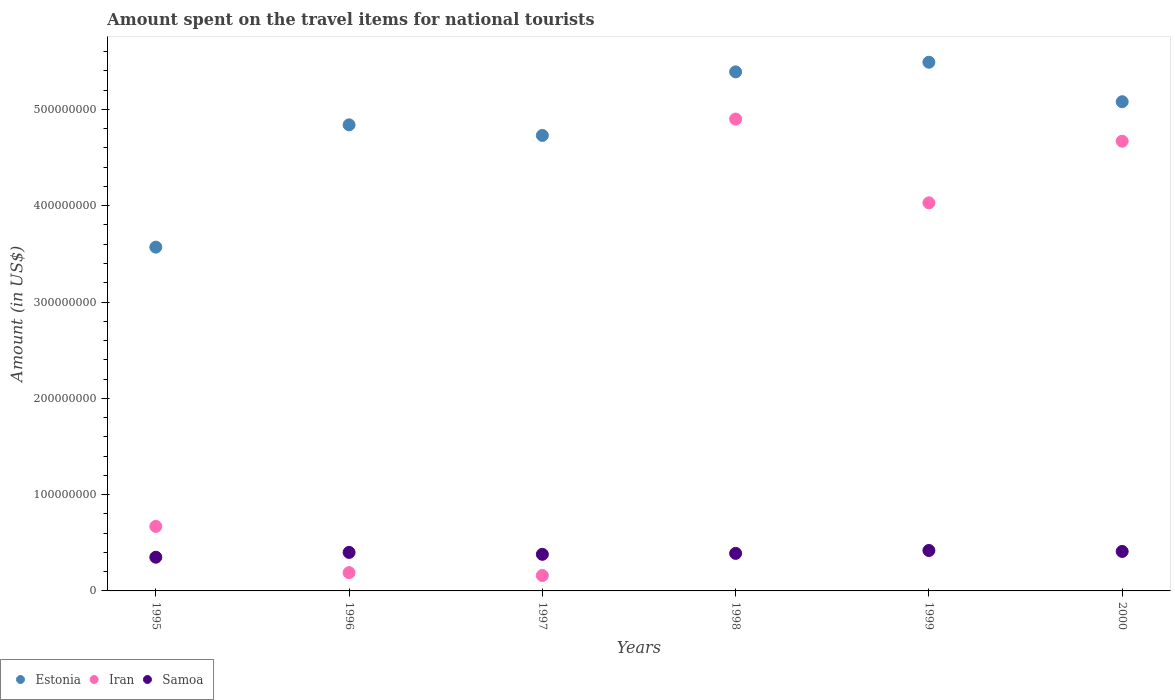How many different coloured dotlines are there?
Your response must be concise. 3. What is the amount spent on the travel items for national tourists in Estonia in 1998?
Your answer should be compact. 5.39e+08. Across all years, what is the maximum amount spent on the travel items for national tourists in Estonia?
Make the answer very short. 5.49e+08. Across all years, what is the minimum amount spent on the travel items for national tourists in Estonia?
Your response must be concise. 3.57e+08. In which year was the amount spent on the travel items for national tourists in Estonia maximum?
Provide a short and direct response. 1999. In which year was the amount spent on the travel items for national tourists in Samoa minimum?
Ensure brevity in your answer.  1995. What is the total amount spent on the travel items for national tourists in Samoa in the graph?
Your answer should be very brief. 2.35e+08. What is the difference between the amount spent on the travel items for national tourists in Samoa in 1995 and that in 1999?
Your response must be concise. -7.00e+06. What is the difference between the amount spent on the travel items for national tourists in Estonia in 1997 and the amount spent on the travel items for national tourists in Iran in 2000?
Provide a succinct answer. 6.00e+06. What is the average amount spent on the travel items for national tourists in Estonia per year?
Your answer should be very brief. 4.85e+08. In the year 1998, what is the difference between the amount spent on the travel items for national tourists in Estonia and amount spent on the travel items for national tourists in Iran?
Provide a succinct answer. 4.90e+07. In how many years, is the amount spent on the travel items for national tourists in Estonia greater than 380000000 US$?
Offer a terse response. 5. What is the ratio of the amount spent on the travel items for national tourists in Estonia in 1996 to that in 1998?
Provide a short and direct response. 0.9. What is the difference between the highest and the second highest amount spent on the travel items for national tourists in Estonia?
Provide a succinct answer. 1.00e+07. What is the difference between the highest and the lowest amount spent on the travel items for national tourists in Samoa?
Your response must be concise. 7.00e+06. Is it the case that in every year, the sum of the amount spent on the travel items for national tourists in Samoa and amount spent on the travel items for national tourists in Iran  is greater than the amount spent on the travel items for national tourists in Estonia?
Keep it short and to the point. No. Are the values on the major ticks of Y-axis written in scientific E-notation?
Make the answer very short. No. Does the graph contain any zero values?
Offer a terse response. No. Does the graph contain grids?
Offer a very short reply. No. How many legend labels are there?
Provide a succinct answer. 3. What is the title of the graph?
Offer a terse response. Amount spent on the travel items for national tourists. What is the label or title of the Y-axis?
Offer a very short reply. Amount (in US$). What is the Amount (in US$) in Estonia in 1995?
Offer a terse response. 3.57e+08. What is the Amount (in US$) of Iran in 1995?
Provide a succinct answer. 6.70e+07. What is the Amount (in US$) of Samoa in 1995?
Make the answer very short. 3.50e+07. What is the Amount (in US$) of Estonia in 1996?
Offer a very short reply. 4.84e+08. What is the Amount (in US$) in Iran in 1996?
Provide a short and direct response. 1.90e+07. What is the Amount (in US$) in Samoa in 1996?
Ensure brevity in your answer.  4.00e+07. What is the Amount (in US$) in Estonia in 1997?
Your answer should be compact. 4.73e+08. What is the Amount (in US$) in Iran in 1997?
Give a very brief answer. 1.60e+07. What is the Amount (in US$) of Samoa in 1997?
Your answer should be compact. 3.80e+07. What is the Amount (in US$) of Estonia in 1998?
Offer a terse response. 5.39e+08. What is the Amount (in US$) in Iran in 1998?
Keep it short and to the point. 4.90e+08. What is the Amount (in US$) of Samoa in 1998?
Offer a terse response. 3.90e+07. What is the Amount (in US$) of Estonia in 1999?
Your answer should be compact. 5.49e+08. What is the Amount (in US$) of Iran in 1999?
Provide a short and direct response. 4.03e+08. What is the Amount (in US$) in Samoa in 1999?
Keep it short and to the point. 4.20e+07. What is the Amount (in US$) in Estonia in 2000?
Your answer should be very brief. 5.08e+08. What is the Amount (in US$) in Iran in 2000?
Your response must be concise. 4.67e+08. What is the Amount (in US$) of Samoa in 2000?
Keep it short and to the point. 4.10e+07. Across all years, what is the maximum Amount (in US$) of Estonia?
Provide a short and direct response. 5.49e+08. Across all years, what is the maximum Amount (in US$) in Iran?
Your answer should be very brief. 4.90e+08. Across all years, what is the maximum Amount (in US$) in Samoa?
Offer a terse response. 4.20e+07. Across all years, what is the minimum Amount (in US$) of Estonia?
Make the answer very short. 3.57e+08. Across all years, what is the minimum Amount (in US$) in Iran?
Ensure brevity in your answer.  1.60e+07. Across all years, what is the minimum Amount (in US$) of Samoa?
Offer a very short reply. 3.50e+07. What is the total Amount (in US$) of Estonia in the graph?
Give a very brief answer. 2.91e+09. What is the total Amount (in US$) in Iran in the graph?
Provide a succinct answer. 1.46e+09. What is the total Amount (in US$) in Samoa in the graph?
Offer a terse response. 2.35e+08. What is the difference between the Amount (in US$) of Estonia in 1995 and that in 1996?
Make the answer very short. -1.27e+08. What is the difference between the Amount (in US$) of Iran in 1995 and that in 1996?
Your answer should be very brief. 4.80e+07. What is the difference between the Amount (in US$) of Samoa in 1995 and that in 1996?
Your answer should be very brief. -5.00e+06. What is the difference between the Amount (in US$) of Estonia in 1995 and that in 1997?
Provide a succinct answer. -1.16e+08. What is the difference between the Amount (in US$) in Iran in 1995 and that in 1997?
Your response must be concise. 5.10e+07. What is the difference between the Amount (in US$) of Samoa in 1995 and that in 1997?
Provide a short and direct response. -3.00e+06. What is the difference between the Amount (in US$) of Estonia in 1995 and that in 1998?
Ensure brevity in your answer.  -1.82e+08. What is the difference between the Amount (in US$) in Iran in 1995 and that in 1998?
Provide a succinct answer. -4.23e+08. What is the difference between the Amount (in US$) in Estonia in 1995 and that in 1999?
Keep it short and to the point. -1.92e+08. What is the difference between the Amount (in US$) in Iran in 1995 and that in 1999?
Offer a very short reply. -3.36e+08. What is the difference between the Amount (in US$) of Samoa in 1995 and that in 1999?
Offer a terse response. -7.00e+06. What is the difference between the Amount (in US$) of Estonia in 1995 and that in 2000?
Your answer should be very brief. -1.51e+08. What is the difference between the Amount (in US$) in Iran in 1995 and that in 2000?
Keep it short and to the point. -4.00e+08. What is the difference between the Amount (in US$) of Samoa in 1995 and that in 2000?
Your response must be concise. -6.00e+06. What is the difference between the Amount (in US$) in Estonia in 1996 and that in 1997?
Keep it short and to the point. 1.10e+07. What is the difference between the Amount (in US$) of Samoa in 1996 and that in 1997?
Your answer should be very brief. 2.00e+06. What is the difference between the Amount (in US$) of Estonia in 1996 and that in 1998?
Offer a terse response. -5.50e+07. What is the difference between the Amount (in US$) in Iran in 1996 and that in 1998?
Provide a short and direct response. -4.71e+08. What is the difference between the Amount (in US$) in Samoa in 1996 and that in 1998?
Ensure brevity in your answer.  1.00e+06. What is the difference between the Amount (in US$) in Estonia in 1996 and that in 1999?
Provide a short and direct response. -6.50e+07. What is the difference between the Amount (in US$) of Iran in 1996 and that in 1999?
Provide a succinct answer. -3.84e+08. What is the difference between the Amount (in US$) of Samoa in 1996 and that in 1999?
Offer a terse response. -2.00e+06. What is the difference between the Amount (in US$) in Estonia in 1996 and that in 2000?
Provide a short and direct response. -2.40e+07. What is the difference between the Amount (in US$) of Iran in 1996 and that in 2000?
Provide a short and direct response. -4.48e+08. What is the difference between the Amount (in US$) in Estonia in 1997 and that in 1998?
Provide a succinct answer. -6.60e+07. What is the difference between the Amount (in US$) in Iran in 1997 and that in 1998?
Give a very brief answer. -4.74e+08. What is the difference between the Amount (in US$) of Samoa in 1997 and that in 1998?
Make the answer very short. -1.00e+06. What is the difference between the Amount (in US$) of Estonia in 1997 and that in 1999?
Provide a short and direct response. -7.60e+07. What is the difference between the Amount (in US$) in Iran in 1997 and that in 1999?
Your answer should be very brief. -3.87e+08. What is the difference between the Amount (in US$) in Estonia in 1997 and that in 2000?
Keep it short and to the point. -3.50e+07. What is the difference between the Amount (in US$) of Iran in 1997 and that in 2000?
Your response must be concise. -4.51e+08. What is the difference between the Amount (in US$) in Samoa in 1997 and that in 2000?
Keep it short and to the point. -3.00e+06. What is the difference between the Amount (in US$) in Estonia in 1998 and that in 1999?
Provide a short and direct response. -1.00e+07. What is the difference between the Amount (in US$) of Iran in 1998 and that in 1999?
Your response must be concise. 8.70e+07. What is the difference between the Amount (in US$) of Estonia in 1998 and that in 2000?
Offer a terse response. 3.10e+07. What is the difference between the Amount (in US$) in Iran in 1998 and that in 2000?
Give a very brief answer. 2.30e+07. What is the difference between the Amount (in US$) in Estonia in 1999 and that in 2000?
Your response must be concise. 4.10e+07. What is the difference between the Amount (in US$) of Iran in 1999 and that in 2000?
Keep it short and to the point. -6.40e+07. What is the difference between the Amount (in US$) of Estonia in 1995 and the Amount (in US$) of Iran in 1996?
Give a very brief answer. 3.38e+08. What is the difference between the Amount (in US$) of Estonia in 1995 and the Amount (in US$) of Samoa in 1996?
Ensure brevity in your answer.  3.17e+08. What is the difference between the Amount (in US$) of Iran in 1995 and the Amount (in US$) of Samoa in 1996?
Offer a terse response. 2.70e+07. What is the difference between the Amount (in US$) of Estonia in 1995 and the Amount (in US$) of Iran in 1997?
Your answer should be compact. 3.41e+08. What is the difference between the Amount (in US$) of Estonia in 1995 and the Amount (in US$) of Samoa in 1997?
Offer a very short reply. 3.19e+08. What is the difference between the Amount (in US$) in Iran in 1995 and the Amount (in US$) in Samoa in 1997?
Give a very brief answer. 2.90e+07. What is the difference between the Amount (in US$) of Estonia in 1995 and the Amount (in US$) of Iran in 1998?
Give a very brief answer. -1.33e+08. What is the difference between the Amount (in US$) of Estonia in 1995 and the Amount (in US$) of Samoa in 1998?
Your answer should be very brief. 3.18e+08. What is the difference between the Amount (in US$) in Iran in 1995 and the Amount (in US$) in Samoa in 1998?
Keep it short and to the point. 2.80e+07. What is the difference between the Amount (in US$) of Estonia in 1995 and the Amount (in US$) of Iran in 1999?
Provide a short and direct response. -4.60e+07. What is the difference between the Amount (in US$) in Estonia in 1995 and the Amount (in US$) in Samoa in 1999?
Make the answer very short. 3.15e+08. What is the difference between the Amount (in US$) of Iran in 1995 and the Amount (in US$) of Samoa in 1999?
Your response must be concise. 2.50e+07. What is the difference between the Amount (in US$) in Estonia in 1995 and the Amount (in US$) in Iran in 2000?
Your answer should be very brief. -1.10e+08. What is the difference between the Amount (in US$) in Estonia in 1995 and the Amount (in US$) in Samoa in 2000?
Keep it short and to the point. 3.16e+08. What is the difference between the Amount (in US$) of Iran in 1995 and the Amount (in US$) of Samoa in 2000?
Offer a very short reply. 2.60e+07. What is the difference between the Amount (in US$) of Estonia in 1996 and the Amount (in US$) of Iran in 1997?
Provide a short and direct response. 4.68e+08. What is the difference between the Amount (in US$) in Estonia in 1996 and the Amount (in US$) in Samoa in 1997?
Offer a very short reply. 4.46e+08. What is the difference between the Amount (in US$) in Iran in 1996 and the Amount (in US$) in Samoa in 1997?
Your answer should be very brief. -1.90e+07. What is the difference between the Amount (in US$) of Estonia in 1996 and the Amount (in US$) of Iran in 1998?
Your answer should be compact. -6.00e+06. What is the difference between the Amount (in US$) in Estonia in 1996 and the Amount (in US$) in Samoa in 1998?
Your response must be concise. 4.45e+08. What is the difference between the Amount (in US$) in Iran in 1996 and the Amount (in US$) in Samoa in 1998?
Give a very brief answer. -2.00e+07. What is the difference between the Amount (in US$) of Estonia in 1996 and the Amount (in US$) of Iran in 1999?
Offer a very short reply. 8.10e+07. What is the difference between the Amount (in US$) in Estonia in 1996 and the Amount (in US$) in Samoa in 1999?
Ensure brevity in your answer.  4.42e+08. What is the difference between the Amount (in US$) in Iran in 1996 and the Amount (in US$) in Samoa in 1999?
Your answer should be compact. -2.30e+07. What is the difference between the Amount (in US$) in Estonia in 1996 and the Amount (in US$) in Iran in 2000?
Offer a very short reply. 1.70e+07. What is the difference between the Amount (in US$) in Estonia in 1996 and the Amount (in US$) in Samoa in 2000?
Give a very brief answer. 4.43e+08. What is the difference between the Amount (in US$) in Iran in 1996 and the Amount (in US$) in Samoa in 2000?
Provide a short and direct response. -2.20e+07. What is the difference between the Amount (in US$) in Estonia in 1997 and the Amount (in US$) in Iran in 1998?
Offer a terse response. -1.70e+07. What is the difference between the Amount (in US$) of Estonia in 1997 and the Amount (in US$) of Samoa in 1998?
Your response must be concise. 4.34e+08. What is the difference between the Amount (in US$) of Iran in 1997 and the Amount (in US$) of Samoa in 1998?
Keep it short and to the point. -2.30e+07. What is the difference between the Amount (in US$) of Estonia in 1997 and the Amount (in US$) of Iran in 1999?
Offer a very short reply. 7.00e+07. What is the difference between the Amount (in US$) in Estonia in 1997 and the Amount (in US$) in Samoa in 1999?
Ensure brevity in your answer.  4.31e+08. What is the difference between the Amount (in US$) in Iran in 1997 and the Amount (in US$) in Samoa in 1999?
Give a very brief answer. -2.60e+07. What is the difference between the Amount (in US$) in Estonia in 1997 and the Amount (in US$) in Samoa in 2000?
Your answer should be very brief. 4.32e+08. What is the difference between the Amount (in US$) in Iran in 1997 and the Amount (in US$) in Samoa in 2000?
Offer a terse response. -2.50e+07. What is the difference between the Amount (in US$) in Estonia in 1998 and the Amount (in US$) in Iran in 1999?
Your answer should be compact. 1.36e+08. What is the difference between the Amount (in US$) of Estonia in 1998 and the Amount (in US$) of Samoa in 1999?
Your response must be concise. 4.97e+08. What is the difference between the Amount (in US$) of Iran in 1998 and the Amount (in US$) of Samoa in 1999?
Provide a short and direct response. 4.48e+08. What is the difference between the Amount (in US$) in Estonia in 1998 and the Amount (in US$) in Iran in 2000?
Your answer should be compact. 7.20e+07. What is the difference between the Amount (in US$) in Estonia in 1998 and the Amount (in US$) in Samoa in 2000?
Make the answer very short. 4.98e+08. What is the difference between the Amount (in US$) of Iran in 1998 and the Amount (in US$) of Samoa in 2000?
Offer a very short reply. 4.49e+08. What is the difference between the Amount (in US$) in Estonia in 1999 and the Amount (in US$) in Iran in 2000?
Keep it short and to the point. 8.20e+07. What is the difference between the Amount (in US$) of Estonia in 1999 and the Amount (in US$) of Samoa in 2000?
Your response must be concise. 5.08e+08. What is the difference between the Amount (in US$) of Iran in 1999 and the Amount (in US$) of Samoa in 2000?
Your answer should be very brief. 3.62e+08. What is the average Amount (in US$) of Estonia per year?
Offer a very short reply. 4.85e+08. What is the average Amount (in US$) of Iran per year?
Your answer should be very brief. 2.44e+08. What is the average Amount (in US$) in Samoa per year?
Your response must be concise. 3.92e+07. In the year 1995, what is the difference between the Amount (in US$) of Estonia and Amount (in US$) of Iran?
Make the answer very short. 2.90e+08. In the year 1995, what is the difference between the Amount (in US$) in Estonia and Amount (in US$) in Samoa?
Give a very brief answer. 3.22e+08. In the year 1995, what is the difference between the Amount (in US$) of Iran and Amount (in US$) of Samoa?
Offer a terse response. 3.20e+07. In the year 1996, what is the difference between the Amount (in US$) in Estonia and Amount (in US$) in Iran?
Your response must be concise. 4.65e+08. In the year 1996, what is the difference between the Amount (in US$) of Estonia and Amount (in US$) of Samoa?
Provide a short and direct response. 4.44e+08. In the year 1996, what is the difference between the Amount (in US$) in Iran and Amount (in US$) in Samoa?
Offer a very short reply. -2.10e+07. In the year 1997, what is the difference between the Amount (in US$) in Estonia and Amount (in US$) in Iran?
Give a very brief answer. 4.57e+08. In the year 1997, what is the difference between the Amount (in US$) in Estonia and Amount (in US$) in Samoa?
Provide a short and direct response. 4.35e+08. In the year 1997, what is the difference between the Amount (in US$) in Iran and Amount (in US$) in Samoa?
Offer a terse response. -2.20e+07. In the year 1998, what is the difference between the Amount (in US$) of Estonia and Amount (in US$) of Iran?
Keep it short and to the point. 4.90e+07. In the year 1998, what is the difference between the Amount (in US$) of Estonia and Amount (in US$) of Samoa?
Give a very brief answer. 5.00e+08. In the year 1998, what is the difference between the Amount (in US$) of Iran and Amount (in US$) of Samoa?
Your response must be concise. 4.51e+08. In the year 1999, what is the difference between the Amount (in US$) of Estonia and Amount (in US$) of Iran?
Ensure brevity in your answer.  1.46e+08. In the year 1999, what is the difference between the Amount (in US$) in Estonia and Amount (in US$) in Samoa?
Ensure brevity in your answer.  5.07e+08. In the year 1999, what is the difference between the Amount (in US$) in Iran and Amount (in US$) in Samoa?
Make the answer very short. 3.61e+08. In the year 2000, what is the difference between the Amount (in US$) in Estonia and Amount (in US$) in Iran?
Make the answer very short. 4.10e+07. In the year 2000, what is the difference between the Amount (in US$) in Estonia and Amount (in US$) in Samoa?
Your response must be concise. 4.67e+08. In the year 2000, what is the difference between the Amount (in US$) of Iran and Amount (in US$) of Samoa?
Make the answer very short. 4.26e+08. What is the ratio of the Amount (in US$) of Estonia in 1995 to that in 1996?
Provide a short and direct response. 0.74. What is the ratio of the Amount (in US$) of Iran in 1995 to that in 1996?
Offer a terse response. 3.53. What is the ratio of the Amount (in US$) of Estonia in 1995 to that in 1997?
Keep it short and to the point. 0.75. What is the ratio of the Amount (in US$) of Iran in 1995 to that in 1997?
Offer a terse response. 4.19. What is the ratio of the Amount (in US$) in Samoa in 1995 to that in 1997?
Your response must be concise. 0.92. What is the ratio of the Amount (in US$) of Estonia in 1995 to that in 1998?
Your answer should be compact. 0.66. What is the ratio of the Amount (in US$) in Iran in 1995 to that in 1998?
Keep it short and to the point. 0.14. What is the ratio of the Amount (in US$) of Samoa in 1995 to that in 1998?
Ensure brevity in your answer.  0.9. What is the ratio of the Amount (in US$) in Estonia in 1995 to that in 1999?
Provide a short and direct response. 0.65. What is the ratio of the Amount (in US$) of Iran in 1995 to that in 1999?
Your answer should be compact. 0.17. What is the ratio of the Amount (in US$) in Estonia in 1995 to that in 2000?
Provide a short and direct response. 0.7. What is the ratio of the Amount (in US$) in Iran in 1995 to that in 2000?
Your answer should be compact. 0.14. What is the ratio of the Amount (in US$) in Samoa in 1995 to that in 2000?
Offer a terse response. 0.85. What is the ratio of the Amount (in US$) in Estonia in 1996 to that in 1997?
Offer a very short reply. 1.02. What is the ratio of the Amount (in US$) in Iran in 1996 to that in 1997?
Provide a short and direct response. 1.19. What is the ratio of the Amount (in US$) in Samoa in 1996 to that in 1997?
Give a very brief answer. 1.05. What is the ratio of the Amount (in US$) in Estonia in 1996 to that in 1998?
Give a very brief answer. 0.9. What is the ratio of the Amount (in US$) of Iran in 1996 to that in 1998?
Ensure brevity in your answer.  0.04. What is the ratio of the Amount (in US$) of Samoa in 1996 to that in 1998?
Your answer should be compact. 1.03. What is the ratio of the Amount (in US$) of Estonia in 1996 to that in 1999?
Make the answer very short. 0.88. What is the ratio of the Amount (in US$) of Iran in 1996 to that in 1999?
Keep it short and to the point. 0.05. What is the ratio of the Amount (in US$) in Samoa in 1996 to that in 1999?
Give a very brief answer. 0.95. What is the ratio of the Amount (in US$) in Estonia in 1996 to that in 2000?
Your response must be concise. 0.95. What is the ratio of the Amount (in US$) in Iran in 1996 to that in 2000?
Your answer should be compact. 0.04. What is the ratio of the Amount (in US$) of Samoa in 1996 to that in 2000?
Give a very brief answer. 0.98. What is the ratio of the Amount (in US$) of Estonia in 1997 to that in 1998?
Provide a succinct answer. 0.88. What is the ratio of the Amount (in US$) of Iran in 1997 to that in 1998?
Ensure brevity in your answer.  0.03. What is the ratio of the Amount (in US$) of Samoa in 1997 to that in 1998?
Offer a very short reply. 0.97. What is the ratio of the Amount (in US$) in Estonia in 1997 to that in 1999?
Offer a very short reply. 0.86. What is the ratio of the Amount (in US$) of Iran in 1997 to that in 1999?
Your response must be concise. 0.04. What is the ratio of the Amount (in US$) of Samoa in 1997 to that in 1999?
Your answer should be compact. 0.9. What is the ratio of the Amount (in US$) of Estonia in 1997 to that in 2000?
Make the answer very short. 0.93. What is the ratio of the Amount (in US$) in Iran in 1997 to that in 2000?
Your answer should be compact. 0.03. What is the ratio of the Amount (in US$) in Samoa in 1997 to that in 2000?
Offer a very short reply. 0.93. What is the ratio of the Amount (in US$) in Estonia in 1998 to that in 1999?
Ensure brevity in your answer.  0.98. What is the ratio of the Amount (in US$) in Iran in 1998 to that in 1999?
Give a very brief answer. 1.22. What is the ratio of the Amount (in US$) in Estonia in 1998 to that in 2000?
Make the answer very short. 1.06. What is the ratio of the Amount (in US$) of Iran in 1998 to that in 2000?
Ensure brevity in your answer.  1.05. What is the ratio of the Amount (in US$) of Samoa in 1998 to that in 2000?
Provide a succinct answer. 0.95. What is the ratio of the Amount (in US$) in Estonia in 1999 to that in 2000?
Make the answer very short. 1.08. What is the ratio of the Amount (in US$) of Iran in 1999 to that in 2000?
Offer a terse response. 0.86. What is the ratio of the Amount (in US$) of Samoa in 1999 to that in 2000?
Ensure brevity in your answer.  1.02. What is the difference between the highest and the second highest Amount (in US$) of Iran?
Provide a short and direct response. 2.30e+07. What is the difference between the highest and the second highest Amount (in US$) in Samoa?
Ensure brevity in your answer.  1.00e+06. What is the difference between the highest and the lowest Amount (in US$) in Estonia?
Make the answer very short. 1.92e+08. What is the difference between the highest and the lowest Amount (in US$) in Iran?
Your answer should be very brief. 4.74e+08. 